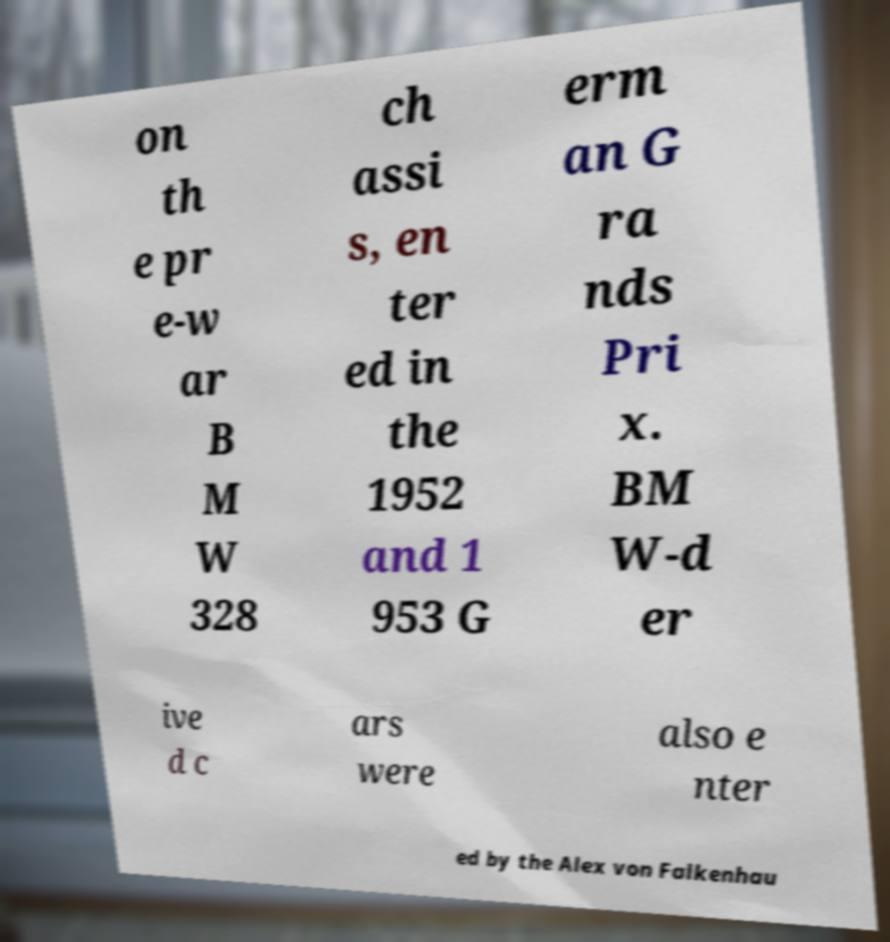Can you read and provide the text displayed in the image?This photo seems to have some interesting text. Can you extract and type it out for me? on th e pr e-w ar B M W 328 ch assi s, en ter ed in the 1952 and 1 953 G erm an G ra nds Pri x. BM W-d er ive d c ars were also e nter ed by the Alex von Falkenhau 